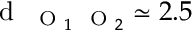<formula> <loc_0><loc_0><loc_500><loc_500>d _ { O _ { 1 } O _ { 2 } } \simeq 2 . 5</formula> 